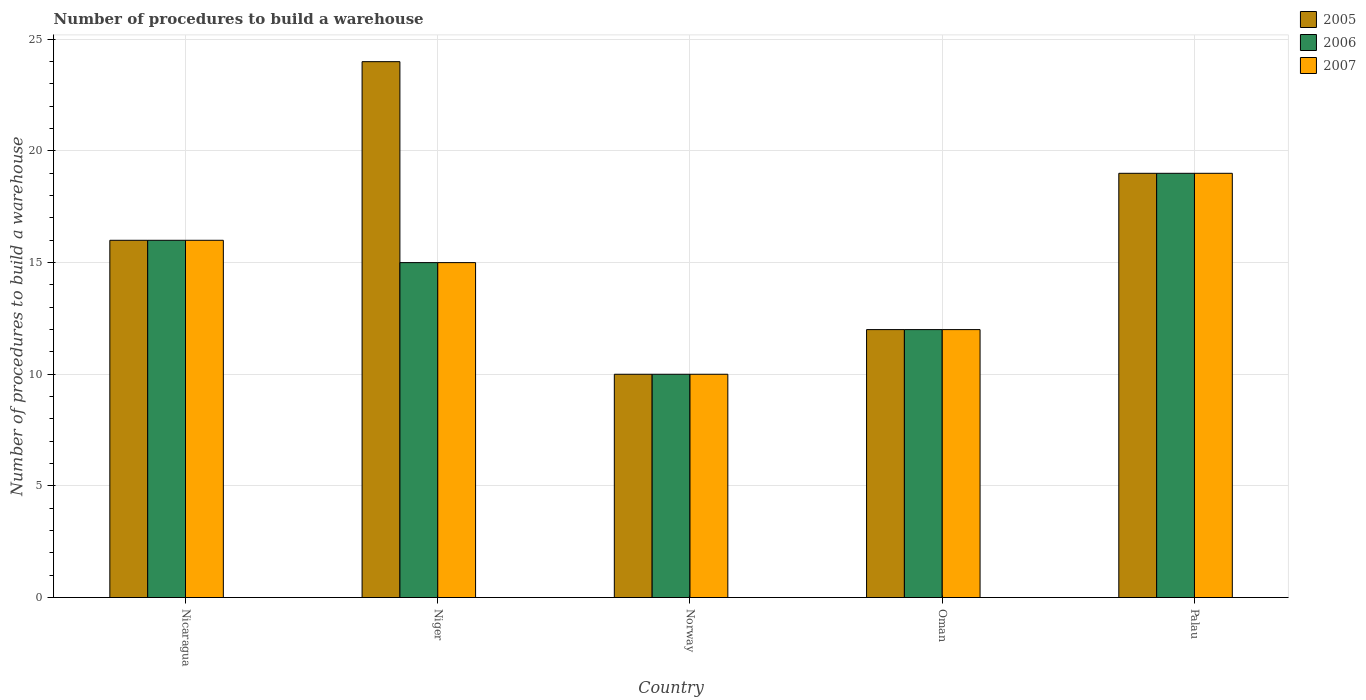What is the label of the 4th group of bars from the left?
Offer a very short reply. Oman. In how many cases, is the number of bars for a given country not equal to the number of legend labels?
Provide a short and direct response. 0. Across all countries, what is the maximum number of procedures to build a warehouse in in 2007?
Make the answer very short. 19. Across all countries, what is the minimum number of procedures to build a warehouse in in 2005?
Give a very brief answer. 10. In which country was the number of procedures to build a warehouse in in 2007 maximum?
Your answer should be very brief. Palau. What is the difference between the number of procedures to build a warehouse in in 2006 in Nicaragua and that in Oman?
Your response must be concise. 4. What is the difference between the number of procedures to build a warehouse in in 2006 in Nicaragua and the number of procedures to build a warehouse in in 2005 in Oman?
Give a very brief answer. 4. What is the average number of procedures to build a warehouse in in 2005 per country?
Ensure brevity in your answer.  16.2. What is the difference between the number of procedures to build a warehouse in of/in 2006 and number of procedures to build a warehouse in of/in 2007 in Palau?
Keep it short and to the point. 0. In how many countries, is the number of procedures to build a warehouse in in 2006 greater than 19?
Your answer should be very brief. 0. What is the ratio of the number of procedures to build a warehouse in in 2007 in Niger to that in Norway?
Provide a succinct answer. 1.5. Is the difference between the number of procedures to build a warehouse in in 2006 in Nicaragua and Palau greater than the difference between the number of procedures to build a warehouse in in 2007 in Nicaragua and Palau?
Make the answer very short. No. What is the difference between the highest and the second highest number of procedures to build a warehouse in in 2006?
Your answer should be very brief. -3. What does the 1st bar from the left in Nicaragua represents?
Ensure brevity in your answer.  2005. Is it the case that in every country, the sum of the number of procedures to build a warehouse in in 2007 and number of procedures to build a warehouse in in 2006 is greater than the number of procedures to build a warehouse in in 2005?
Make the answer very short. Yes. How many bars are there?
Your answer should be compact. 15. Are all the bars in the graph horizontal?
Your answer should be compact. No. How many countries are there in the graph?
Make the answer very short. 5. What is the difference between two consecutive major ticks on the Y-axis?
Ensure brevity in your answer.  5. Does the graph contain any zero values?
Make the answer very short. No. Does the graph contain grids?
Your response must be concise. Yes. Where does the legend appear in the graph?
Keep it short and to the point. Top right. How are the legend labels stacked?
Offer a very short reply. Vertical. What is the title of the graph?
Your response must be concise. Number of procedures to build a warehouse. Does "2013" appear as one of the legend labels in the graph?
Keep it short and to the point. No. What is the label or title of the X-axis?
Provide a short and direct response. Country. What is the label or title of the Y-axis?
Offer a very short reply. Number of procedures to build a warehouse. What is the Number of procedures to build a warehouse in 2005 in Nicaragua?
Your answer should be very brief. 16. What is the Number of procedures to build a warehouse of 2005 in Niger?
Your answer should be compact. 24. What is the Number of procedures to build a warehouse of 2006 in Niger?
Keep it short and to the point. 15. What is the Number of procedures to build a warehouse of 2007 in Niger?
Provide a short and direct response. 15. What is the Number of procedures to build a warehouse in 2005 in Oman?
Make the answer very short. 12. What is the Number of procedures to build a warehouse of 2005 in Palau?
Make the answer very short. 19. What is the Number of procedures to build a warehouse in 2006 in Palau?
Provide a succinct answer. 19. What is the Number of procedures to build a warehouse in 2007 in Palau?
Your answer should be compact. 19. Across all countries, what is the maximum Number of procedures to build a warehouse of 2005?
Offer a terse response. 24. Across all countries, what is the maximum Number of procedures to build a warehouse in 2006?
Provide a short and direct response. 19. Across all countries, what is the minimum Number of procedures to build a warehouse of 2007?
Give a very brief answer. 10. What is the total Number of procedures to build a warehouse of 2005 in the graph?
Provide a succinct answer. 81. What is the difference between the Number of procedures to build a warehouse of 2006 in Nicaragua and that in Niger?
Provide a succinct answer. 1. What is the difference between the Number of procedures to build a warehouse of 2005 in Nicaragua and that in Norway?
Offer a terse response. 6. What is the difference between the Number of procedures to build a warehouse of 2005 in Nicaragua and that in Oman?
Make the answer very short. 4. What is the difference between the Number of procedures to build a warehouse of 2006 in Nicaragua and that in Palau?
Keep it short and to the point. -3. What is the difference between the Number of procedures to build a warehouse of 2005 in Niger and that in Norway?
Provide a short and direct response. 14. What is the difference between the Number of procedures to build a warehouse of 2006 in Niger and that in Norway?
Offer a very short reply. 5. What is the difference between the Number of procedures to build a warehouse in 2005 in Niger and that in Oman?
Your answer should be very brief. 12. What is the difference between the Number of procedures to build a warehouse in 2005 in Niger and that in Palau?
Offer a terse response. 5. What is the difference between the Number of procedures to build a warehouse in 2006 in Niger and that in Palau?
Offer a terse response. -4. What is the difference between the Number of procedures to build a warehouse in 2006 in Norway and that in Oman?
Your answer should be compact. -2. What is the difference between the Number of procedures to build a warehouse in 2005 in Norway and that in Palau?
Make the answer very short. -9. What is the difference between the Number of procedures to build a warehouse in 2006 in Norway and that in Palau?
Offer a terse response. -9. What is the difference between the Number of procedures to build a warehouse of 2007 in Norway and that in Palau?
Keep it short and to the point. -9. What is the difference between the Number of procedures to build a warehouse of 2005 in Nicaragua and the Number of procedures to build a warehouse of 2007 in Niger?
Offer a terse response. 1. What is the difference between the Number of procedures to build a warehouse of 2005 in Nicaragua and the Number of procedures to build a warehouse of 2006 in Norway?
Offer a very short reply. 6. What is the difference between the Number of procedures to build a warehouse in 2005 in Nicaragua and the Number of procedures to build a warehouse in 2007 in Norway?
Keep it short and to the point. 6. What is the difference between the Number of procedures to build a warehouse of 2005 in Nicaragua and the Number of procedures to build a warehouse of 2007 in Oman?
Offer a terse response. 4. What is the difference between the Number of procedures to build a warehouse in 2006 in Nicaragua and the Number of procedures to build a warehouse in 2007 in Oman?
Provide a short and direct response. 4. What is the difference between the Number of procedures to build a warehouse in 2005 in Nicaragua and the Number of procedures to build a warehouse in 2006 in Palau?
Your answer should be very brief. -3. What is the difference between the Number of procedures to build a warehouse in 2006 in Niger and the Number of procedures to build a warehouse in 2007 in Norway?
Your answer should be very brief. 5. What is the difference between the Number of procedures to build a warehouse in 2005 in Niger and the Number of procedures to build a warehouse in 2006 in Oman?
Keep it short and to the point. 12. What is the difference between the Number of procedures to build a warehouse in 2005 in Niger and the Number of procedures to build a warehouse in 2007 in Oman?
Your answer should be very brief. 12. What is the difference between the Number of procedures to build a warehouse in 2006 in Niger and the Number of procedures to build a warehouse in 2007 in Oman?
Your answer should be compact. 3. What is the difference between the Number of procedures to build a warehouse of 2005 in Norway and the Number of procedures to build a warehouse of 2007 in Oman?
Ensure brevity in your answer.  -2. What is the difference between the Number of procedures to build a warehouse in 2006 in Norway and the Number of procedures to build a warehouse in 2007 in Palau?
Keep it short and to the point. -9. What is the difference between the Number of procedures to build a warehouse in 2005 in Oman and the Number of procedures to build a warehouse in 2007 in Palau?
Give a very brief answer. -7. What is the average Number of procedures to build a warehouse of 2006 per country?
Provide a succinct answer. 14.4. What is the average Number of procedures to build a warehouse in 2007 per country?
Your answer should be very brief. 14.4. What is the difference between the Number of procedures to build a warehouse in 2005 and Number of procedures to build a warehouse in 2006 in Niger?
Offer a terse response. 9. What is the difference between the Number of procedures to build a warehouse of 2005 and Number of procedures to build a warehouse of 2006 in Oman?
Offer a very short reply. 0. What is the ratio of the Number of procedures to build a warehouse of 2005 in Nicaragua to that in Niger?
Keep it short and to the point. 0.67. What is the ratio of the Number of procedures to build a warehouse of 2006 in Nicaragua to that in Niger?
Keep it short and to the point. 1.07. What is the ratio of the Number of procedures to build a warehouse of 2007 in Nicaragua to that in Niger?
Provide a succinct answer. 1.07. What is the ratio of the Number of procedures to build a warehouse of 2005 in Nicaragua to that in Norway?
Keep it short and to the point. 1.6. What is the ratio of the Number of procedures to build a warehouse of 2005 in Nicaragua to that in Oman?
Provide a short and direct response. 1.33. What is the ratio of the Number of procedures to build a warehouse in 2006 in Nicaragua to that in Oman?
Your response must be concise. 1.33. What is the ratio of the Number of procedures to build a warehouse in 2005 in Nicaragua to that in Palau?
Offer a terse response. 0.84. What is the ratio of the Number of procedures to build a warehouse in 2006 in Nicaragua to that in Palau?
Make the answer very short. 0.84. What is the ratio of the Number of procedures to build a warehouse in 2007 in Nicaragua to that in Palau?
Provide a succinct answer. 0.84. What is the ratio of the Number of procedures to build a warehouse in 2005 in Niger to that in Norway?
Your answer should be very brief. 2.4. What is the ratio of the Number of procedures to build a warehouse of 2007 in Niger to that in Oman?
Make the answer very short. 1.25. What is the ratio of the Number of procedures to build a warehouse in 2005 in Niger to that in Palau?
Your response must be concise. 1.26. What is the ratio of the Number of procedures to build a warehouse of 2006 in Niger to that in Palau?
Make the answer very short. 0.79. What is the ratio of the Number of procedures to build a warehouse in 2007 in Niger to that in Palau?
Your response must be concise. 0.79. What is the ratio of the Number of procedures to build a warehouse of 2005 in Norway to that in Palau?
Your answer should be very brief. 0.53. What is the ratio of the Number of procedures to build a warehouse of 2006 in Norway to that in Palau?
Provide a short and direct response. 0.53. What is the ratio of the Number of procedures to build a warehouse of 2007 in Norway to that in Palau?
Provide a succinct answer. 0.53. What is the ratio of the Number of procedures to build a warehouse of 2005 in Oman to that in Palau?
Offer a terse response. 0.63. What is the ratio of the Number of procedures to build a warehouse in 2006 in Oman to that in Palau?
Offer a very short reply. 0.63. What is the ratio of the Number of procedures to build a warehouse in 2007 in Oman to that in Palau?
Ensure brevity in your answer.  0.63. What is the difference between the highest and the second highest Number of procedures to build a warehouse of 2006?
Your response must be concise. 3. What is the difference between the highest and the lowest Number of procedures to build a warehouse in 2005?
Give a very brief answer. 14. What is the difference between the highest and the lowest Number of procedures to build a warehouse of 2007?
Your answer should be very brief. 9. 